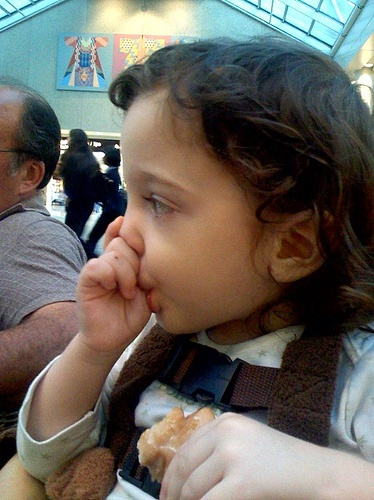Describe the objects in this image and their specific colors. I can see people in cyan, black, gray, and maroon tones, people in cyan, gray, and black tones, people in cyan, black, ivory, gray, and darkgray tones, donut in cyan, tan, and darkgray tones, and people in cyan, black, navy, and gray tones in this image. 